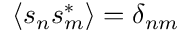<formula> <loc_0><loc_0><loc_500><loc_500>\langle s _ { n } s _ { m } ^ { \ast } \rangle = \delta _ { n m }</formula> 